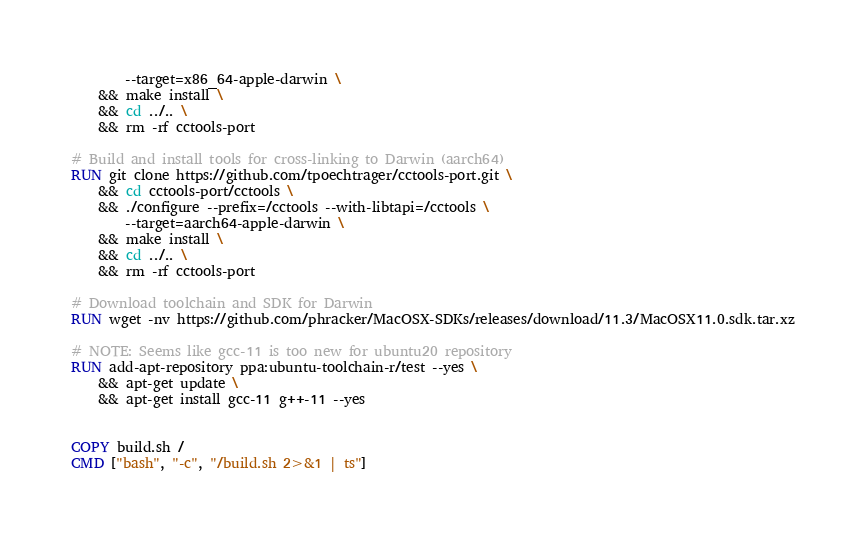Convert code to text. <code><loc_0><loc_0><loc_500><loc_500><_Dockerfile_>        --target=x86_64-apple-darwin \
    && make install \
    && cd ../.. \
    && rm -rf cctools-port

# Build and install tools for cross-linking to Darwin (aarch64)
RUN git clone https://github.com/tpoechtrager/cctools-port.git \
    && cd cctools-port/cctools \
    && ./configure --prefix=/cctools --with-libtapi=/cctools \
        --target=aarch64-apple-darwin \
    && make install \
    && cd ../.. \
    && rm -rf cctools-port

# Download toolchain and SDK for Darwin
RUN wget -nv https://github.com/phracker/MacOSX-SDKs/releases/download/11.3/MacOSX11.0.sdk.tar.xz

# NOTE: Seems like gcc-11 is too new for ubuntu20 repository
RUN add-apt-repository ppa:ubuntu-toolchain-r/test --yes \
    && apt-get update \
    && apt-get install gcc-11 g++-11 --yes


COPY build.sh /
CMD ["bash", "-c", "/build.sh 2>&1 | ts"]
</code> 